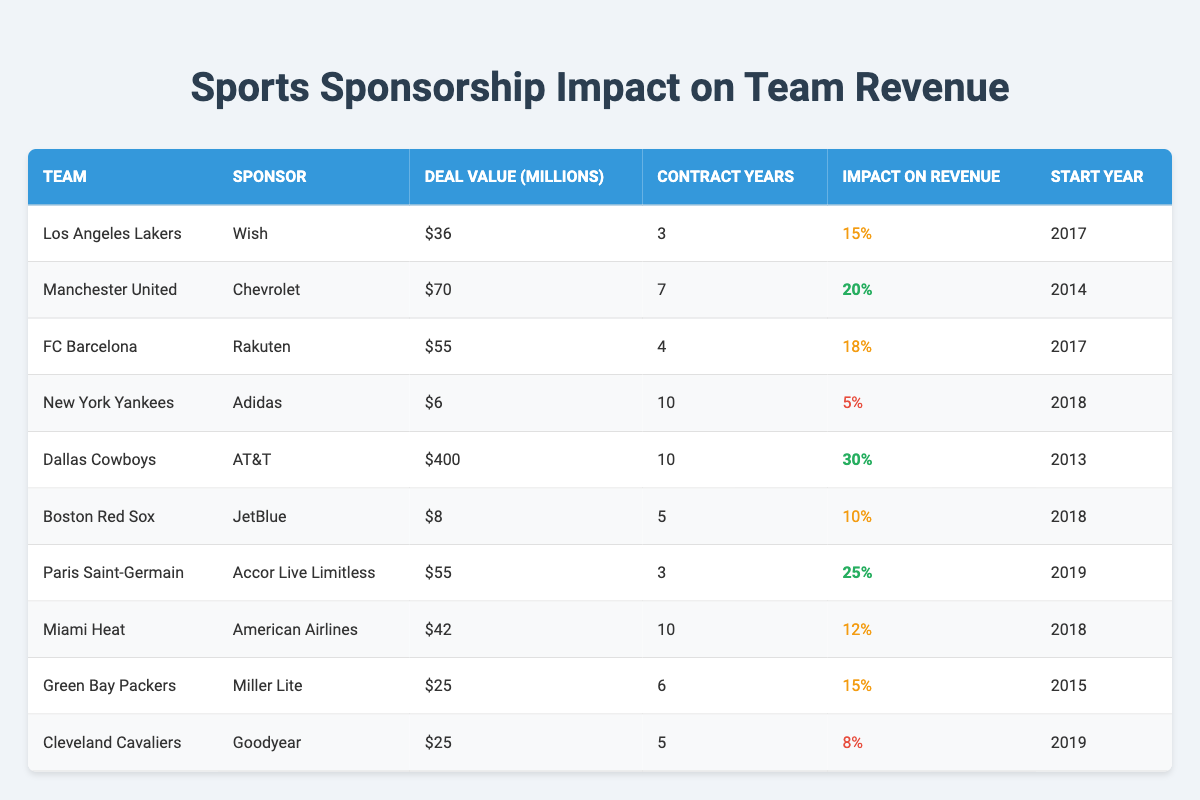What is the sponsorship deal value of the Dallas Cowboys? The Dallas Cowboys have a sponsorship deal valued at 400 million dollars, as stated directly in the table under the 'Deal Value (Millions)' column.
Answer: 400 million Which team has the highest impact on revenue percentage? According to the table, the Dallas Cowboys have the highest impact on revenue percentage at 30%, outlined in the 'Impact on Revenue' column.
Answer: Dallas Cowboys What is the total deal value for teams that started their contracts in 2018? The teams that started their contracts in 2018 and their deal values are: New York Yankees (6 million), Boston Red Sox (8 million), Miami Heat (42 million). Summing these gives us 6 + 8 + 42 = 56 million.
Answer: 56 million Is the impact on revenue for the Miami Heat greater than or equal to 10%? The Miami Heat's impact on revenue percentage is specifically listed as 12%, which is indeed greater than 10%. Thus, the statement is true.
Answer: Yes What is the average impact on revenue percentage for all teams in the table? To find the average, we need to sum all the impact percentages: 15 + 20 + 18 + 5 + 30 + 10 + 25 + 12 + 15 + 8 =  143. There are 10 teams, so average = 143/10 = 14.3.
Answer: 14.3 Which sponsor is associated with the Green Bay Packers? From the table, it is clear that the Green Bay Packers are sponsored by Miller Lite, as indicated in the 'Sponsor' column.
Answer: Miller Lite What is the total contract duration for all teams sponsored by Adidas? The New York Yankees, who are sponsored by Adidas, have a contract duration of 10 years, and since there are no other teams shown in the table with Adidas sponsorship, the total is 10 years.
Answer: 10 years Are there any teams that have a revenue impact percentage of 8% or lower? Yes, the New York Yankees with 5% and Cleveland Cavaliers with 8% show impacts that meet this criterion, so the statement is true.
Answer: Yes What is the difference in revenue impact percentage between the highest and lowest teams? The highest revenue impact percentage is 30% (Dallas Cowboys) and the lowest is 5% (New York Yankees). Therefore, the difference is 30 - 5 = 25%.
Answer: 25% 